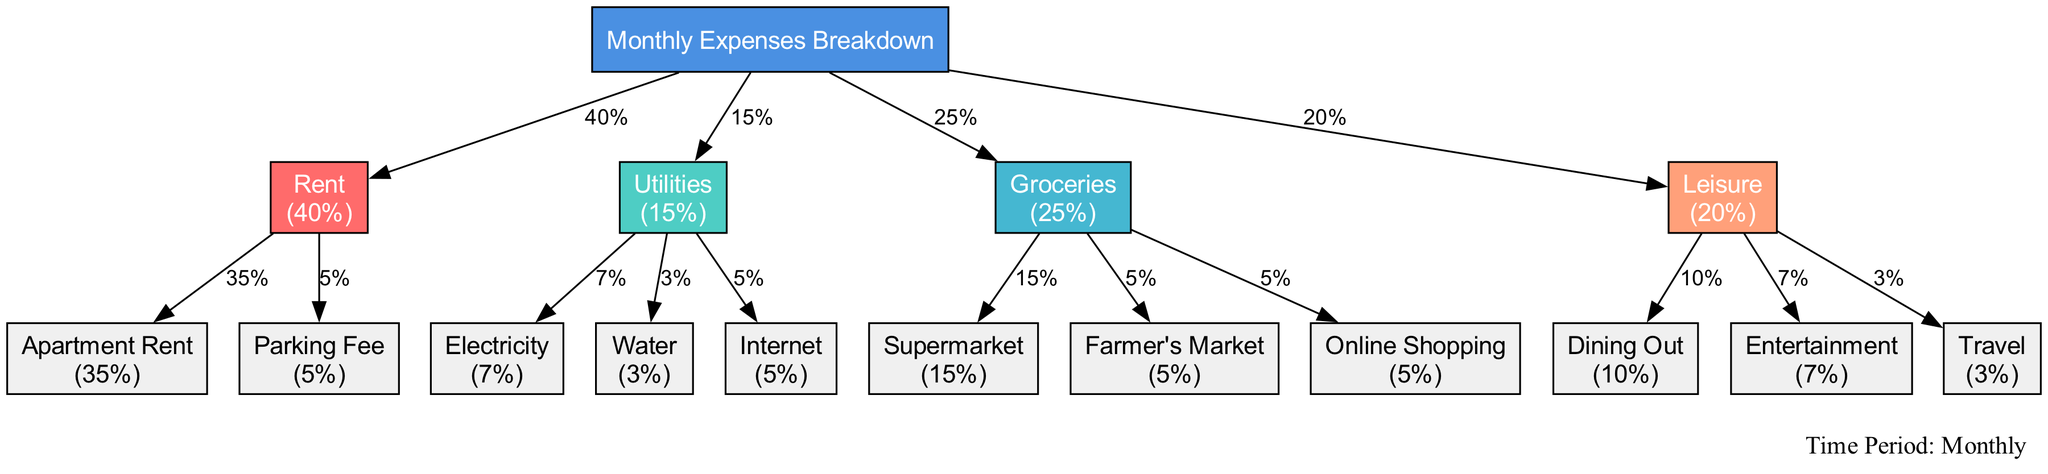What is the total percentage allocated to rent? The diagram indicates that rent contributes 40% of the total expenses. This value is clearly labeled within the relevant node for rent.
Answer: 40% What sub-category contributes the most under groceries? In the groceries category, the sub-category named "Supermarket" has the highest proportion at 15%. This is directly stated in the diagram's sub-category node.
Answer: Supermarket How many sub-categories are listed under the utilities category? The utilities category includes three sub-categories: Electricity, Water, and Internet. By counting each sub-category in the visual, we arrive at the total.
Answer: 3 What is the proportion of leisure expenses? The diagram shows the leisure category takes up 20% of the total expenses. This figure is encapsulated within the leisure node in the diagram.
Answer: 20% Which category has the second highest proportion overall? By examining all categories, utilities at 15% is the second highest after rent at 40%. This conclusion is reached by comparing the proportions displayed in the respective nodes.
Answer: Utilities What percentage of groceries is spent on online shopping? Under the groceries category, the online shopping sub-category indicates a proportion of 5%. This is noted in the sub-category's label in the diagram.
Answer: 5% How much more is spent on dining out compared to travel? The difference between dining out (10%) and travel (3%) is calculated as 10% - 3% = 7%. This comparison is made by referencing both sub-category labels in the leisure category.
Answer: 7% Which is the least expensive category? The utilities category is the least expensive with a proportion of 15%. This is the smallest value when comparing the main categories highlighted in the diagram.
Answer: Utilities What is the total percentage of expenses that go towards groceries and leisure combined? Combining the proportions of groceries (25%) and leisure (20%) gives a total of 25% + 20% = 45%. This is derived by summing the two category figures as shown.
Answer: 45% 